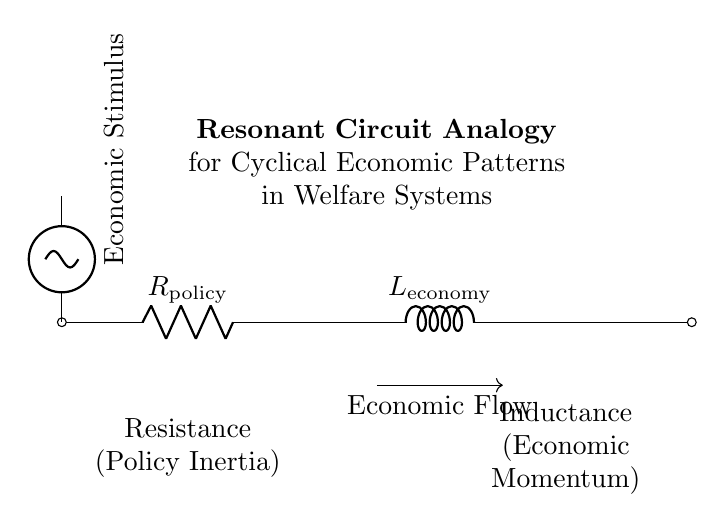What is the component labeled R in this circuit? The component labeled R is the policy resistance, which represents the resistance to changes in welfare policy.
Answer: policy resistance What does the component labeled L represent? The component labeled L is the economic inductance, indicating the momentum of the economy in the welfare system.
Answer: economic momentum What type of voltage source is present in the circuit? The circuit features a sinusoidal voltage source, which implies that the economic stimulus is varying over time.
Answer: sinusoidal voltage source How is economic flow depicted in the circuit? Economic flow is illustrated with a directional arrow, indicating the flow of economic resources through the system.
Answer: directional arrow What analogy does this circuit provide for economic patterns? The circuit serves as a resonant circuit analogy for cyclical economic patterns, highlighting interactions between resistance and inductance in welfare systems.
Answer: resonant circuit analogy How do the elements R and L interact in this analogy? Elements R (policy resistance) and L (economic momentum) interact to create cyclical patterns, where inertia in policies affects economic responses and momentum.
Answer: cyclical patterns What is indicated by the label "Economic Stimulus"? The label "Economic Stimulus" indicates the source of input energy (voltage) that drives the fluctuations in economic activity within the system.
Answer: source of input energy 